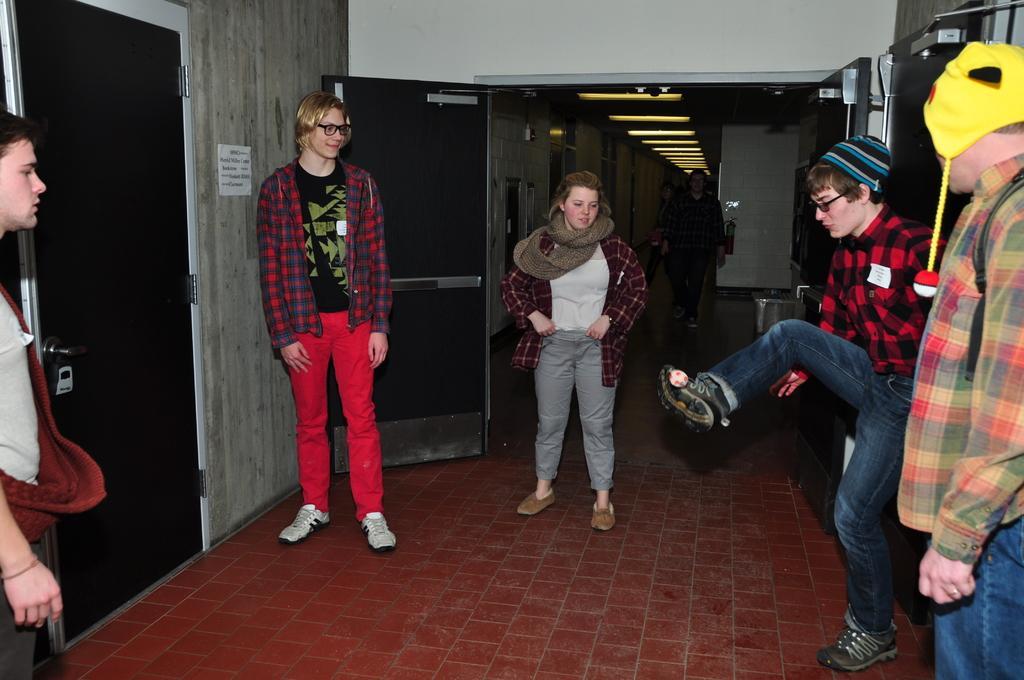Could you give a brief overview of what you see in this image? This picture shows few people standing and a man playing with a ball with his leg and couple of men wore caps on their head and we see few people walking and we see doors. 